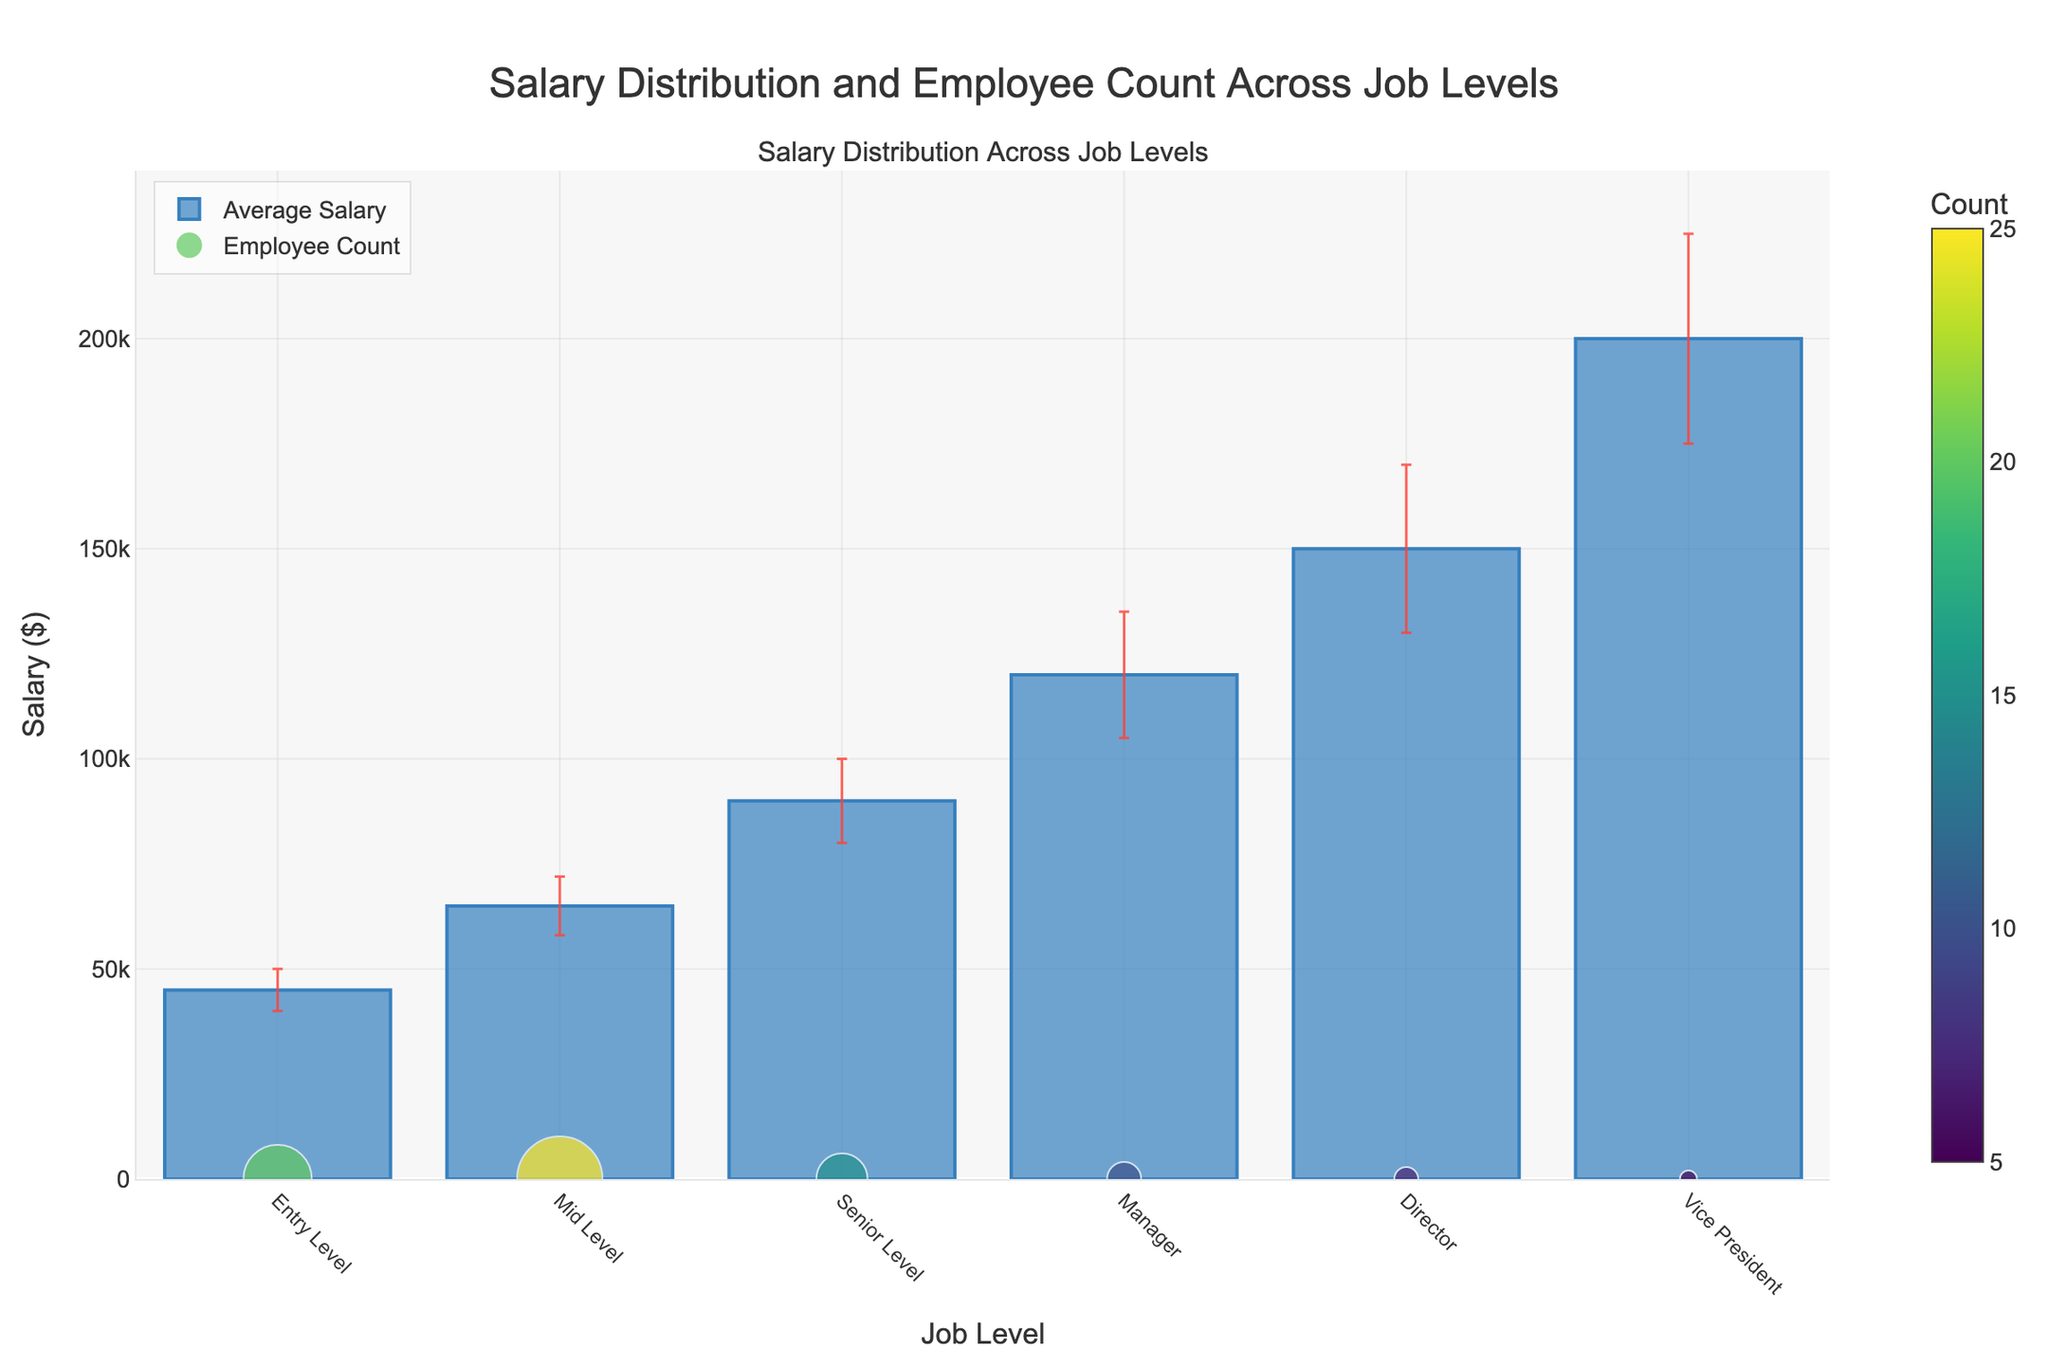what is the title of the plot? The title of the plot is located at the top center of the figure. It is clearly displayed to provide context about the visuals.
Answer: Salary Distribution and Employee Count Across Job Levels How many job levels are represented in the plot? The x-axis lists the different job levels represented in the plot. Counting these labels gives the total number of job levels.
Answer: 6 What is the error bar color? The color of the error bars is detailed in the plot's legend or can be inferred from their appearance in the figure.
Answer: Red Which job level has the highest average salary? Refer to the height of the bars on the y-axis, where the highest bar indicates the job level with the highest average salary.
Answer: Vice President What is the count of employees at the Senior Level? The scatter plot element of the figure shows the count as individual points, and the legend or the color bar indicates the count for each job level.
Answer: 15 Which job level shows the greatest variability in salary? The length of the error bars indicates variability. The job level with the longest error bar has the greatest variability.
Answer: Vice President What is the difference in average salary between the Mid Level and Senior Level? Subtract the average salary of the Mid Level from that of the Senior Level by referring to the heights of their respective bars.
Answer: $25,000 What is the range of the y-axis? The y-axis range is visually specified from the minimum value to the maximum value. Observe the axis labels.
Answer: 0 to approximately 240,000 Which job level has the smallest error bar, indicating the least salary variability? Observing the error bars' lengths, the job level with the shortest error bar depicts the least salary variability.
Answer: Entry Level 